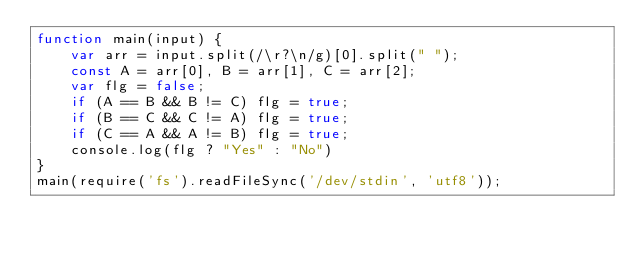Convert code to text. <code><loc_0><loc_0><loc_500><loc_500><_JavaScript_>function main(input) {
    var arr = input.split(/\r?\n/g)[0].split(" ");
    const A = arr[0], B = arr[1], C = arr[2];
    var flg = false;
    if (A == B && B != C) flg = true;
    if (B == C && C != A) flg = true;
    if (C == A && A != B) flg = true;
    console.log(flg ? "Yes" : "No")
}
main(require('fs').readFileSync('/dev/stdin', 'utf8'));</code> 